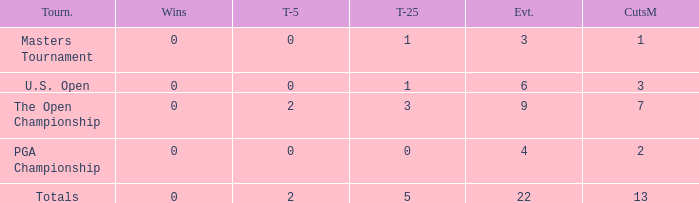How many total cuts were made in events with more than 0 wins and exactly 0 top-5s? 0.0. 